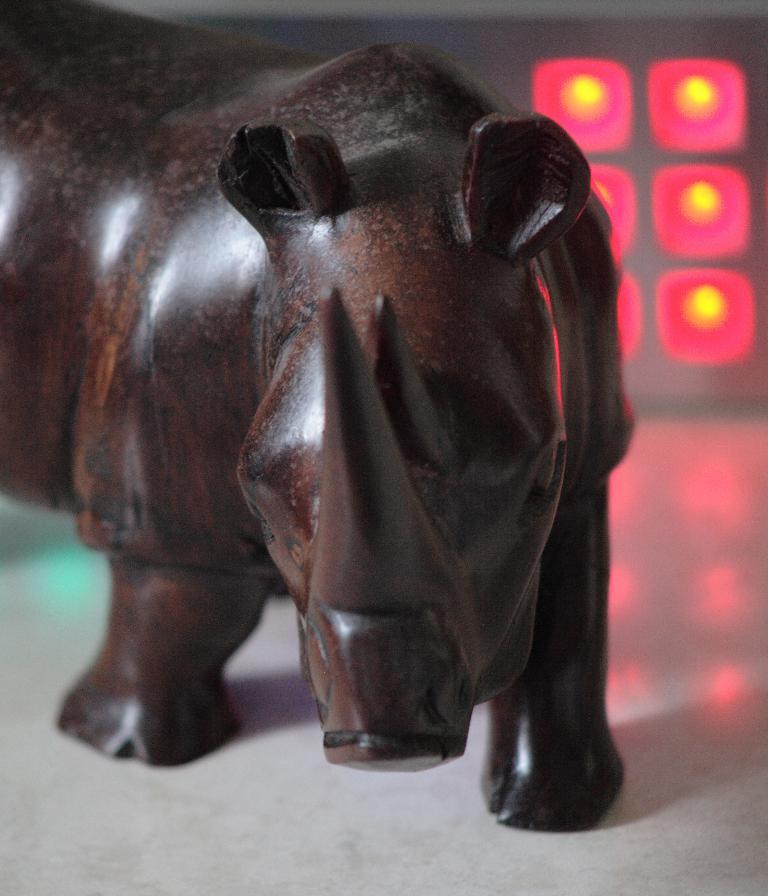What type of animal is depicted in the image? There is a wooden rhino in the image. What else can be seen in the image besides the wooden rhino? There are lights in the top right of the image. Can you tell me how many windows are visible in the image? There are no windows present in the image; it features a wooden rhino and lights. What type of rhythm is being played by the wooden rhino in the image? The wooden rhino is an inanimate object and cannot play any rhythm. 